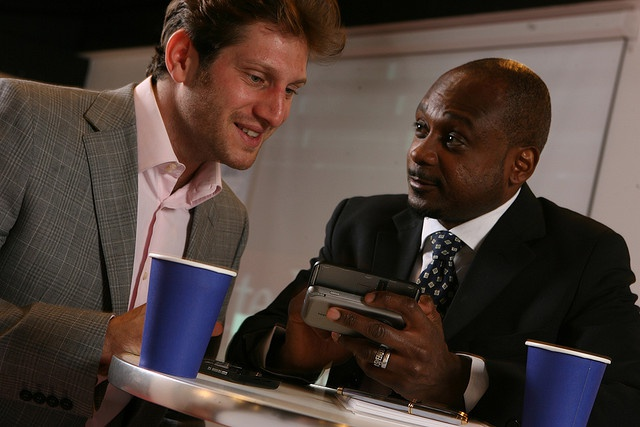Describe the objects in this image and their specific colors. I can see people in black, maroon, gray, and darkgray tones, people in black, maroon, and gray tones, dining table in black, darkgray, and gray tones, cup in black, navy, darkblue, and lightgray tones, and cup in black, navy, lightgray, and darkgray tones in this image. 